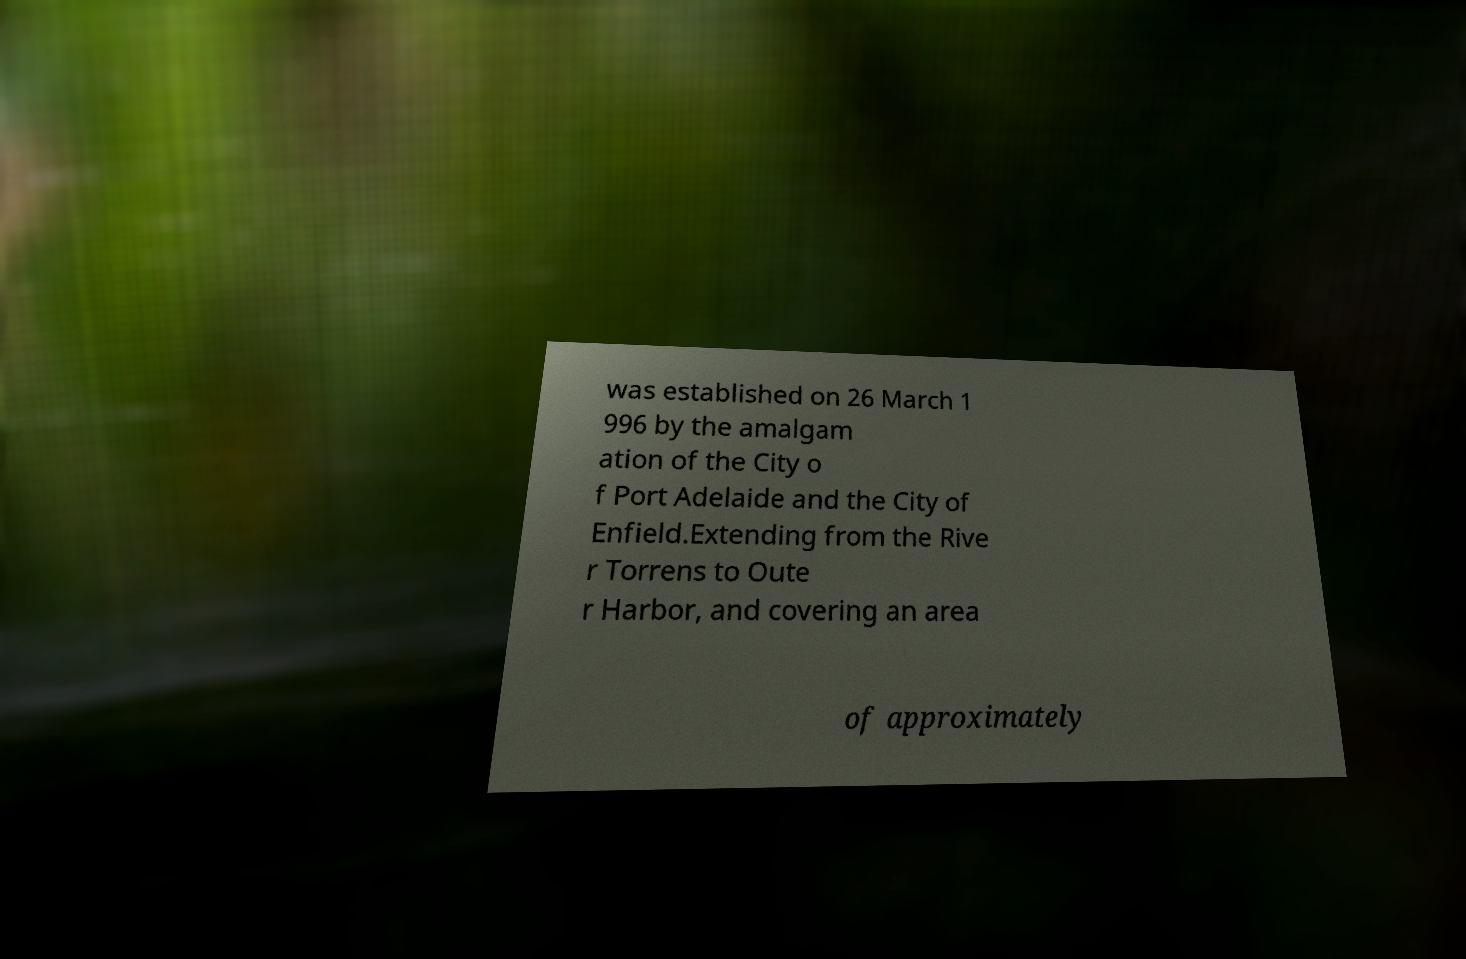Can you read and provide the text displayed in the image?This photo seems to have some interesting text. Can you extract and type it out for me? was established on 26 March 1 996 by the amalgam ation of the City o f Port Adelaide and the City of Enfield.Extending from the Rive r Torrens to Oute r Harbor, and covering an area of approximately 